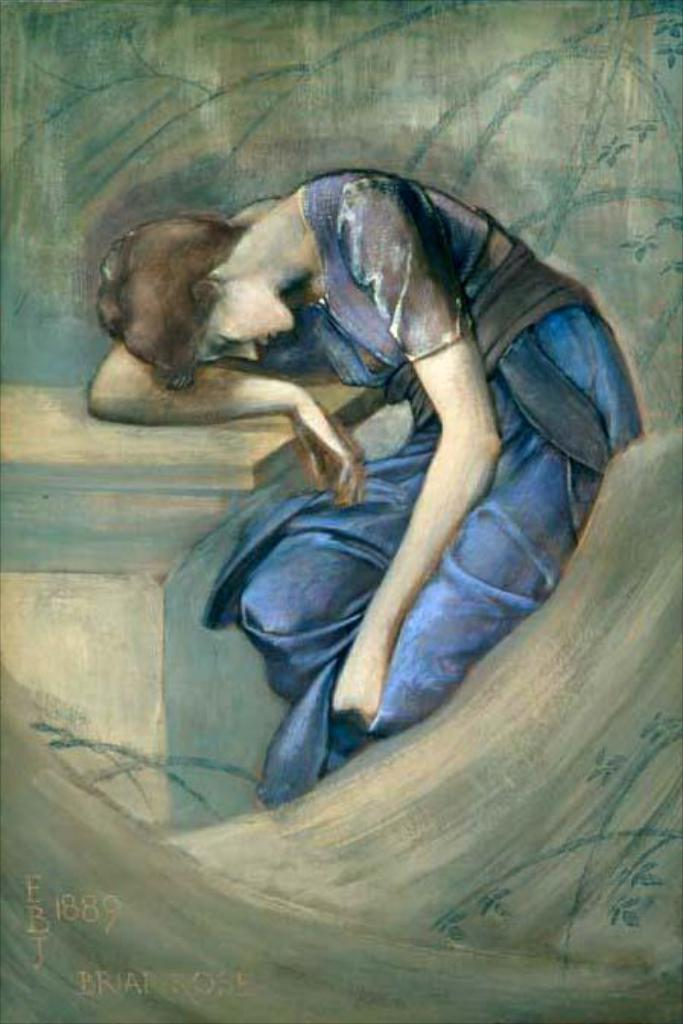What is the main subject of the image? There is a painting in the image. What is depicted in the painting? The painting depicts a woman. What is the woman doing in the painting? The woman is leaning on a table. Where is the table located in the painting? The table is on the left side of the painting. Can you see the parent of the woman in the painting? There is no parent depicted in the painting; it only shows the woman leaning on a table. 